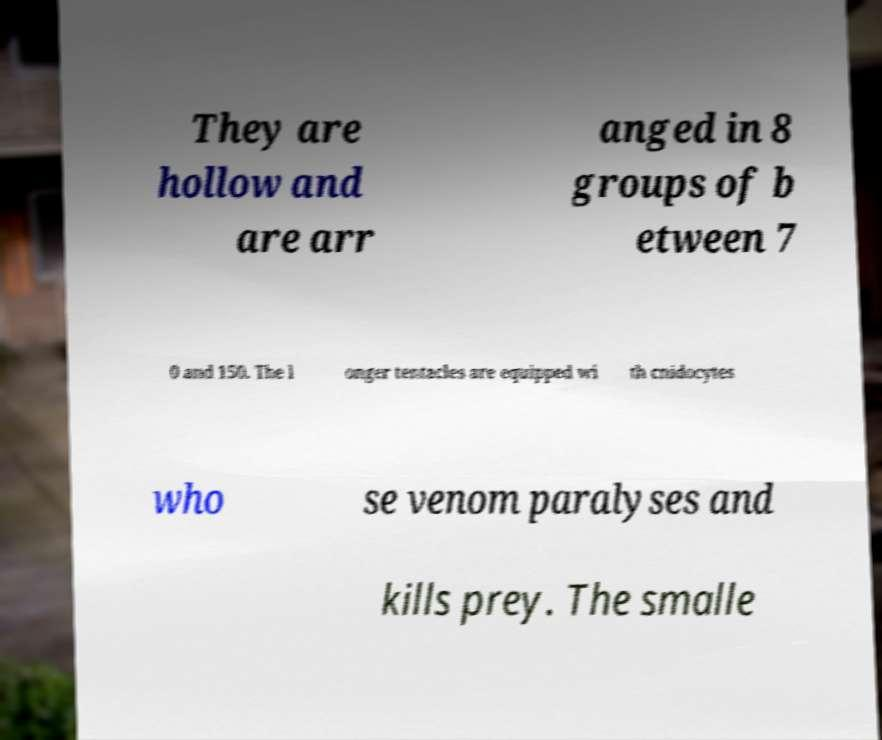Could you extract and type out the text from this image? They are hollow and are arr anged in 8 groups of b etween 7 0 and 150. The l onger tentacles are equipped wi th cnidocytes who se venom paralyses and kills prey. The smalle 